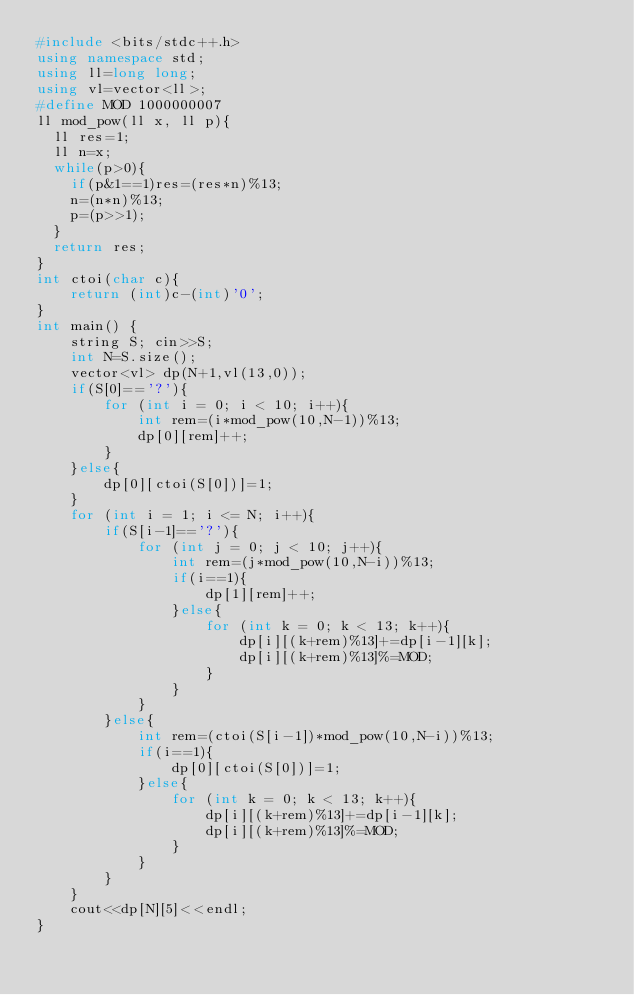Convert code to text. <code><loc_0><loc_0><loc_500><loc_500><_C++_>#include <bits/stdc++.h>
using namespace std;
using ll=long long;
using vl=vector<ll>;
#define MOD 1000000007
ll mod_pow(ll x, ll p){
	ll res=1;
	ll n=x;
	while(p>0){
		if(p&1==1)res=(res*n)%13;
		n=(n*n)%13;
		p=(p>>1);
	}
	return res;
}
int ctoi(char c){
    return (int)c-(int)'0';
}
int main() {
    string S; cin>>S;
    int N=S.size();
    vector<vl> dp(N+1,vl(13,0));
    if(S[0]=='?'){
        for (int i = 0; i < 10; i++){
            int rem=(i*mod_pow(10,N-1))%13;
            dp[0][rem]++;
        }
    }else{
        dp[0][ctoi(S[0])]=1;
    }
    for (int i = 1; i <= N; i++){
        if(S[i-1]=='?'){
            for (int j = 0; j < 10; j++){
                int rem=(j*mod_pow(10,N-i))%13;
                if(i==1){
                    dp[1][rem]++;
                }else{
                    for (int k = 0; k < 13; k++){
                        dp[i][(k+rem)%13]+=dp[i-1][k];
                        dp[i][(k+rem)%13]%=MOD;
                    }
                }
            }
        }else{
            int rem=(ctoi(S[i-1])*mod_pow(10,N-i))%13;
            if(i==1){
                dp[0][ctoi(S[0])]=1;
            }else{
                for (int k = 0; k < 13; k++){
                    dp[i][(k+rem)%13]+=dp[i-1][k];
                    dp[i][(k+rem)%13]%=MOD;
                }
            }
        }
    }
    cout<<dp[N][5]<<endl;
}</code> 